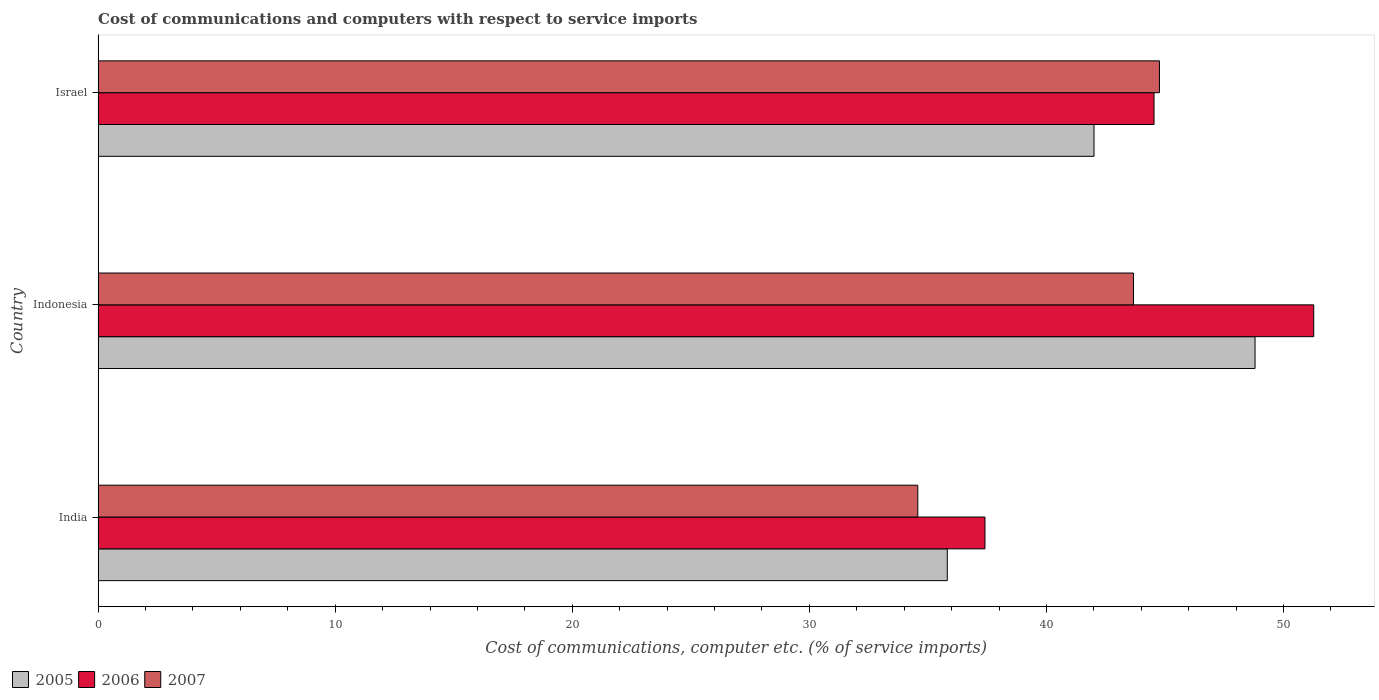How many groups of bars are there?
Your response must be concise. 3. Are the number of bars on each tick of the Y-axis equal?
Offer a terse response. Yes. How many bars are there on the 1st tick from the top?
Provide a short and direct response. 3. What is the label of the 3rd group of bars from the top?
Your response must be concise. India. In how many cases, is the number of bars for a given country not equal to the number of legend labels?
Provide a succinct answer. 0. What is the cost of communications and computers in 2007 in Indonesia?
Offer a very short reply. 43.67. Across all countries, what is the maximum cost of communications and computers in 2006?
Provide a short and direct response. 51.27. Across all countries, what is the minimum cost of communications and computers in 2005?
Ensure brevity in your answer.  35.82. In which country was the cost of communications and computers in 2007 maximum?
Your response must be concise. Israel. In which country was the cost of communications and computers in 2005 minimum?
Ensure brevity in your answer.  India. What is the total cost of communications and computers in 2007 in the graph?
Make the answer very short. 123.01. What is the difference between the cost of communications and computers in 2005 in India and that in Israel?
Your response must be concise. -6.19. What is the difference between the cost of communications and computers in 2006 in Israel and the cost of communications and computers in 2007 in India?
Your answer should be compact. 9.96. What is the average cost of communications and computers in 2006 per country?
Keep it short and to the point. 44.41. What is the difference between the cost of communications and computers in 2007 and cost of communications and computers in 2006 in Indonesia?
Ensure brevity in your answer.  -7.6. What is the ratio of the cost of communications and computers in 2006 in Indonesia to that in Israel?
Your response must be concise. 1.15. What is the difference between the highest and the second highest cost of communications and computers in 2007?
Your response must be concise. 1.1. What is the difference between the highest and the lowest cost of communications and computers in 2005?
Ensure brevity in your answer.  12.98. What does the 3rd bar from the top in India represents?
Make the answer very short. 2005. What does the 2nd bar from the bottom in India represents?
Offer a very short reply. 2006. Is it the case that in every country, the sum of the cost of communications and computers in 2005 and cost of communications and computers in 2006 is greater than the cost of communications and computers in 2007?
Your answer should be very brief. Yes. What is the difference between two consecutive major ticks on the X-axis?
Offer a very short reply. 10. Does the graph contain any zero values?
Ensure brevity in your answer.  No. Where does the legend appear in the graph?
Keep it short and to the point. Bottom left. How many legend labels are there?
Your answer should be compact. 3. What is the title of the graph?
Ensure brevity in your answer.  Cost of communications and computers with respect to service imports. What is the label or title of the X-axis?
Ensure brevity in your answer.  Cost of communications, computer etc. (% of service imports). What is the label or title of the Y-axis?
Make the answer very short. Country. What is the Cost of communications, computer etc. (% of service imports) of 2005 in India?
Give a very brief answer. 35.82. What is the Cost of communications, computer etc. (% of service imports) of 2006 in India?
Offer a terse response. 37.41. What is the Cost of communications, computer etc. (% of service imports) of 2007 in India?
Offer a very short reply. 34.57. What is the Cost of communications, computer etc. (% of service imports) of 2005 in Indonesia?
Make the answer very short. 48.8. What is the Cost of communications, computer etc. (% of service imports) in 2006 in Indonesia?
Give a very brief answer. 51.27. What is the Cost of communications, computer etc. (% of service imports) in 2007 in Indonesia?
Ensure brevity in your answer.  43.67. What is the Cost of communications, computer etc. (% of service imports) in 2005 in Israel?
Offer a terse response. 42.01. What is the Cost of communications, computer etc. (% of service imports) of 2006 in Israel?
Offer a terse response. 44.54. What is the Cost of communications, computer etc. (% of service imports) in 2007 in Israel?
Provide a succinct answer. 44.77. Across all countries, what is the maximum Cost of communications, computer etc. (% of service imports) of 2005?
Your answer should be compact. 48.8. Across all countries, what is the maximum Cost of communications, computer etc. (% of service imports) in 2006?
Offer a terse response. 51.27. Across all countries, what is the maximum Cost of communications, computer etc. (% of service imports) in 2007?
Offer a very short reply. 44.77. Across all countries, what is the minimum Cost of communications, computer etc. (% of service imports) of 2005?
Offer a very short reply. 35.82. Across all countries, what is the minimum Cost of communications, computer etc. (% of service imports) of 2006?
Provide a short and direct response. 37.41. Across all countries, what is the minimum Cost of communications, computer etc. (% of service imports) in 2007?
Offer a terse response. 34.57. What is the total Cost of communications, computer etc. (% of service imports) of 2005 in the graph?
Your answer should be very brief. 126.63. What is the total Cost of communications, computer etc. (% of service imports) in 2006 in the graph?
Give a very brief answer. 133.22. What is the total Cost of communications, computer etc. (% of service imports) in 2007 in the graph?
Offer a terse response. 123.01. What is the difference between the Cost of communications, computer etc. (% of service imports) in 2005 in India and that in Indonesia?
Your response must be concise. -12.98. What is the difference between the Cost of communications, computer etc. (% of service imports) in 2006 in India and that in Indonesia?
Give a very brief answer. -13.87. What is the difference between the Cost of communications, computer etc. (% of service imports) in 2007 in India and that in Indonesia?
Make the answer very short. -9.1. What is the difference between the Cost of communications, computer etc. (% of service imports) in 2005 in India and that in Israel?
Give a very brief answer. -6.19. What is the difference between the Cost of communications, computer etc. (% of service imports) in 2006 in India and that in Israel?
Ensure brevity in your answer.  -7.13. What is the difference between the Cost of communications, computer etc. (% of service imports) in 2007 in India and that in Israel?
Offer a terse response. -10.19. What is the difference between the Cost of communications, computer etc. (% of service imports) of 2005 in Indonesia and that in Israel?
Provide a short and direct response. 6.79. What is the difference between the Cost of communications, computer etc. (% of service imports) of 2006 in Indonesia and that in Israel?
Keep it short and to the point. 6.74. What is the difference between the Cost of communications, computer etc. (% of service imports) of 2007 in Indonesia and that in Israel?
Provide a succinct answer. -1.1. What is the difference between the Cost of communications, computer etc. (% of service imports) in 2005 in India and the Cost of communications, computer etc. (% of service imports) in 2006 in Indonesia?
Provide a succinct answer. -15.46. What is the difference between the Cost of communications, computer etc. (% of service imports) of 2005 in India and the Cost of communications, computer etc. (% of service imports) of 2007 in Indonesia?
Offer a terse response. -7.85. What is the difference between the Cost of communications, computer etc. (% of service imports) of 2006 in India and the Cost of communications, computer etc. (% of service imports) of 2007 in Indonesia?
Provide a short and direct response. -6.26. What is the difference between the Cost of communications, computer etc. (% of service imports) of 2005 in India and the Cost of communications, computer etc. (% of service imports) of 2006 in Israel?
Offer a terse response. -8.72. What is the difference between the Cost of communications, computer etc. (% of service imports) in 2005 in India and the Cost of communications, computer etc. (% of service imports) in 2007 in Israel?
Keep it short and to the point. -8.95. What is the difference between the Cost of communications, computer etc. (% of service imports) of 2006 in India and the Cost of communications, computer etc. (% of service imports) of 2007 in Israel?
Your response must be concise. -7.36. What is the difference between the Cost of communications, computer etc. (% of service imports) in 2005 in Indonesia and the Cost of communications, computer etc. (% of service imports) in 2006 in Israel?
Offer a terse response. 4.26. What is the difference between the Cost of communications, computer etc. (% of service imports) in 2005 in Indonesia and the Cost of communications, computer etc. (% of service imports) in 2007 in Israel?
Your answer should be very brief. 4.03. What is the difference between the Cost of communications, computer etc. (% of service imports) in 2006 in Indonesia and the Cost of communications, computer etc. (% of service imports) in 2007 in Israel?
Ensure brevity in your answer.  6.51. What is the average Cost of communications, computer etc. (% of service imports) in 2005 per country?
Your response must be concise. 42.21. What is the average Cost of communications, computer etc. (% of service imports) of 2006 per country?
Offer a terse response. 44.41. What is the average Cost of communications, computer etc. (% of service imports) in 2007 per country?
Keep it short and to the point. 41. What is the difference between the Cost of communications, computer etc. (% of service imports) in 2005 and Cost of communications, computer etc. (% of service imports) in 2006 in India?
Make the answer very short. -1.59. What is the difference between the Cost of communications, computer etc. (% of service imports) of 2005 and Cost of communications, computer etc. (% of service imports) of 2007 in India?
Ensure brevity in your answer.  1.24. What is the difference between the Cost of communications, computer etc. (% of service imports) in 2006 and Cost of communications, computer etc. (% of service imports) in 2007 in India?
Offer a terse response. 2.83. What is the difference between the Cost of communications, computer etc. (% of service imports) in 2005 and Cost of communications, computer etc. (% of service imports) in 2006 in Indonesia?
Keep it short and to the point. -2.47. What is the difference between the Cost of communications, computer etc. (% of service imports) in 2005 and Cost of communications, computer etc. (% of service imports) in 2007 in Indonesia?
Your answer should be compact. 5.13. What is the difference between the Cost of communications, computer etc. (% of service imports) of 2006 and Cost of communications, computer etc. (% of service imports) of 2007 in Indonesia?
Your answer should be compact. 7.6. What is the difference between the Cost of communications, computer etc. (% of service imports) of 2005 and Cost of communications, computer etc. (% of service imports) of 2006 in Israel?
Give a very brief answer. -2.53. What is the difference between the Cost of communications, computer etc. (% of service imports) in 2005 and Cost of communications, computer etc. (% of service imports) in 2007 in Israel?
Make the answer very short. -2.76. What is the difference between the Cost of communications, computer etc. (% of service imports) of 2006 and Cost of communications, computer etc. (% of service imports) of 2007 in Israel?
Keep it short and to the point. -0.23. What is the ratio of the Cost of communications, computer etc. (% of service imports) of 2005 in India to that in Indonesia?
Give a very brief answer. 0.73. What is the ratio of the Cost of communications, computer etc. (% of service imports) in 2006 in India to that in Indonesia?
Your response must be concise. 0.73. What is the ratio of the Cost of communications, computer etc. (% of service imports) in 2007 in India to that in Indonesia?
Your response must be concise. 0.79. What is the ratio of the Cost of communications, computer etc. (% of service imports) of 2005 in India to that in Israel?
Ensure brevity in your answer.  0.85. What is the ratio of the Cost of communications, computer etc. (% of service imports) of 2006 in India to that in Israel?
Ensure brevity in your answer.  0.84. What is the ratio of the Cost of communications, computer etc. (% of service imports) in 2007 in India to that in Israel?
Offer a terse response. 0.77. What is the ratio of the Cost of communications, computer etc. (% of service imports) in 2005 in Indonesia to that in Israel?
Offer a terse response. 1.16. What is the ratio of the Cost of communications, computer etc. (% of service imports) in 2006 in Indonesia to that in Israel?
Your answer should be very brief. 1.15. What is the ratio of the Cost of communications, computer etc. (% of service imports) in 2007 in Indonesia to that in Israel?
Keep it short and to the point. 0.98. What is the difference between the highest and the second highest Cost of communications, computer etc. (% of service imports) in 2005?
Provide a succinct answer. 6.79. What is the difference between the highest and the second highest Cost of communications, computer etc. (% of service imports) of 2006?
Give a very brief answer. 6.74. What is the difference between the highest and the second highest Cost of communications, computer etc. (% of service imports) of 2007?
Your answer should be very brief. 1.1. What is the difference between the highest and the lowest Cost of communications, computer etc. (% of service imports) in 2005?
Provide a short and direct response. 12.98. What is the difference between the highest and the lowest Cost of communications, computer etc. (% of service imports) in 2006?
Make the answer very short. 13.87. What is the difference between the highest and the lowest Cost of communications, computer etc. (% of service imports) of 2007?
Keep it short and to the point. 10.19. 